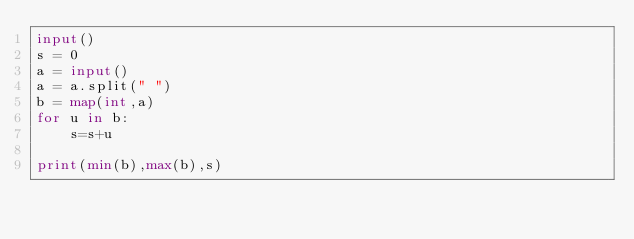Convert code to text. <code><loc_0><loc_0><loc_500><loc_500><_Python_>input()
s = 0
a = input()
a = a.split(" ")
b = map(int,a)
for u in b:
    s=s+u

print(min(b),max(b),s)
</code> 